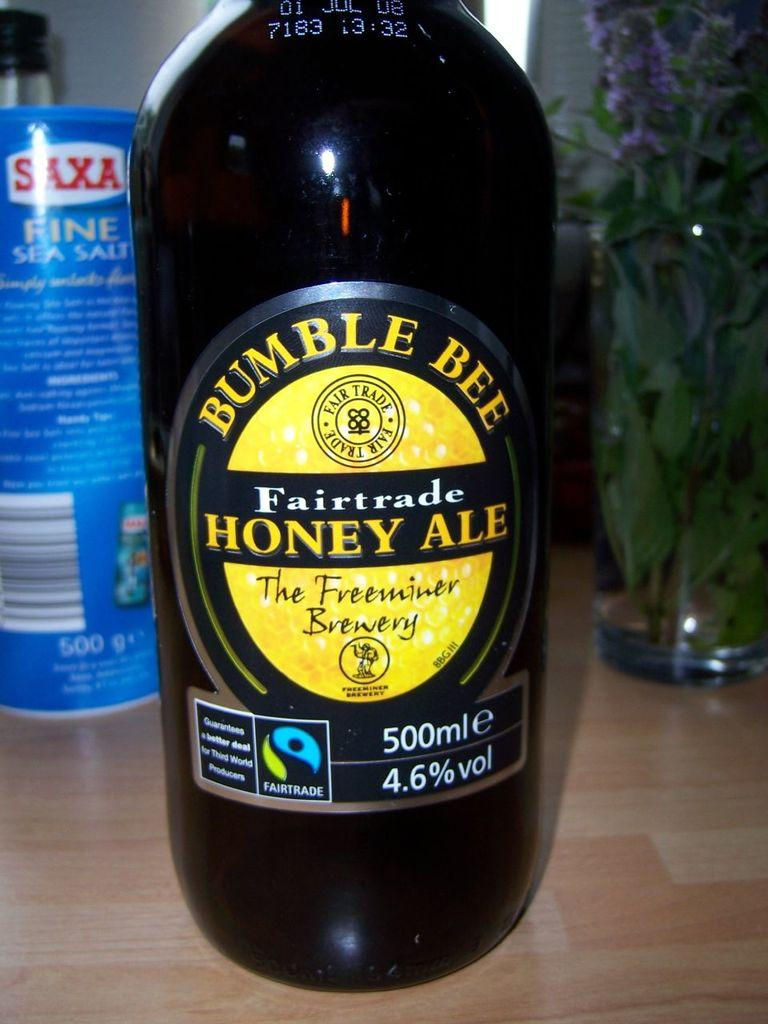<image>
Write a terse but informative summary of the picture. A bottle of Bumble Bee Fairtrade Honey ale which holds 500ml and has an alcohol content of 4.6% 